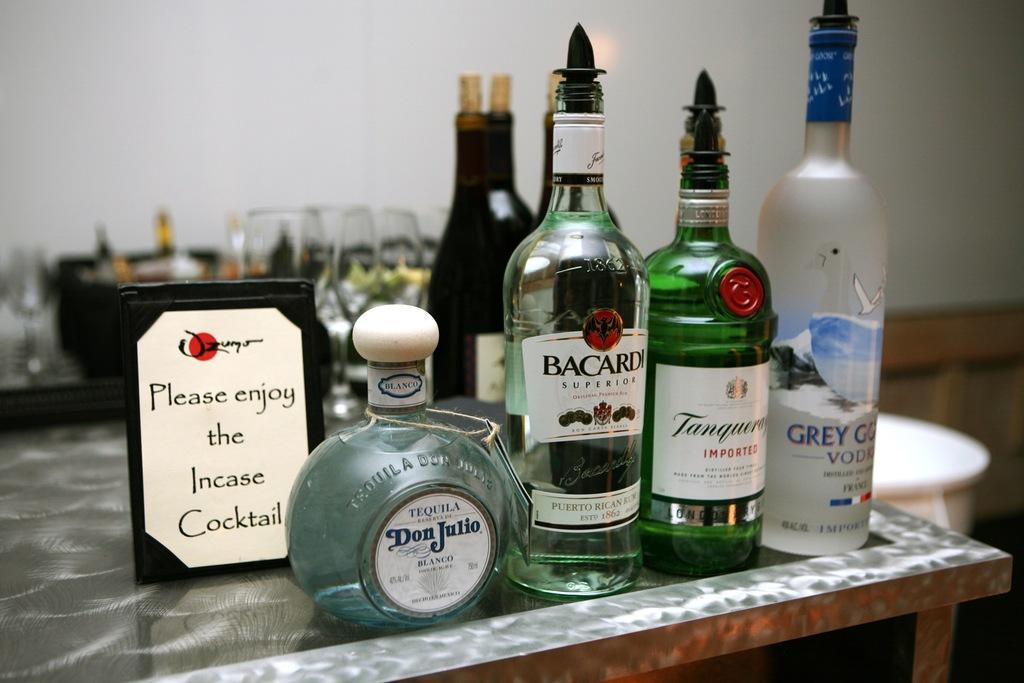Describe this image in one or two sentences. In the background of the picture we can see a wall. Here we can see different bottles and a board on the table. Behind to the bottles we can see glasses. 